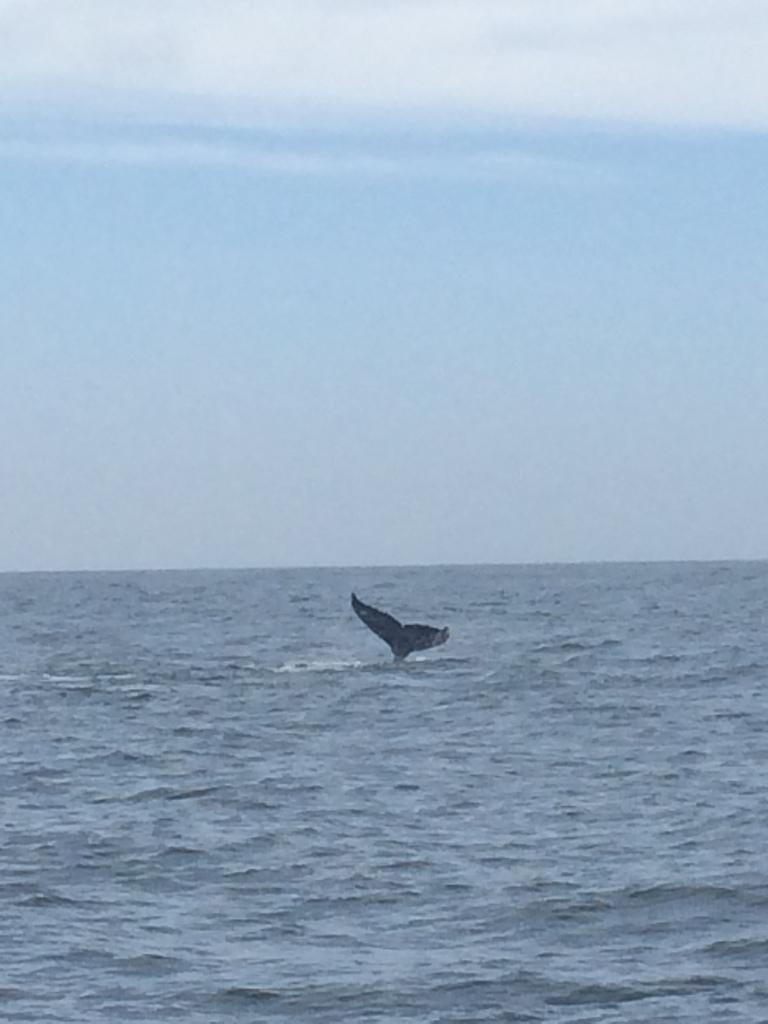What is in the water in the image? There is a shark tail in the water. What can be seen in the background of the image? The sky is visible in the background of the image. What type of reaction can be seen from the farmer in the image? There is no farmer present in the image, so it is not possible to determine any reactions. 